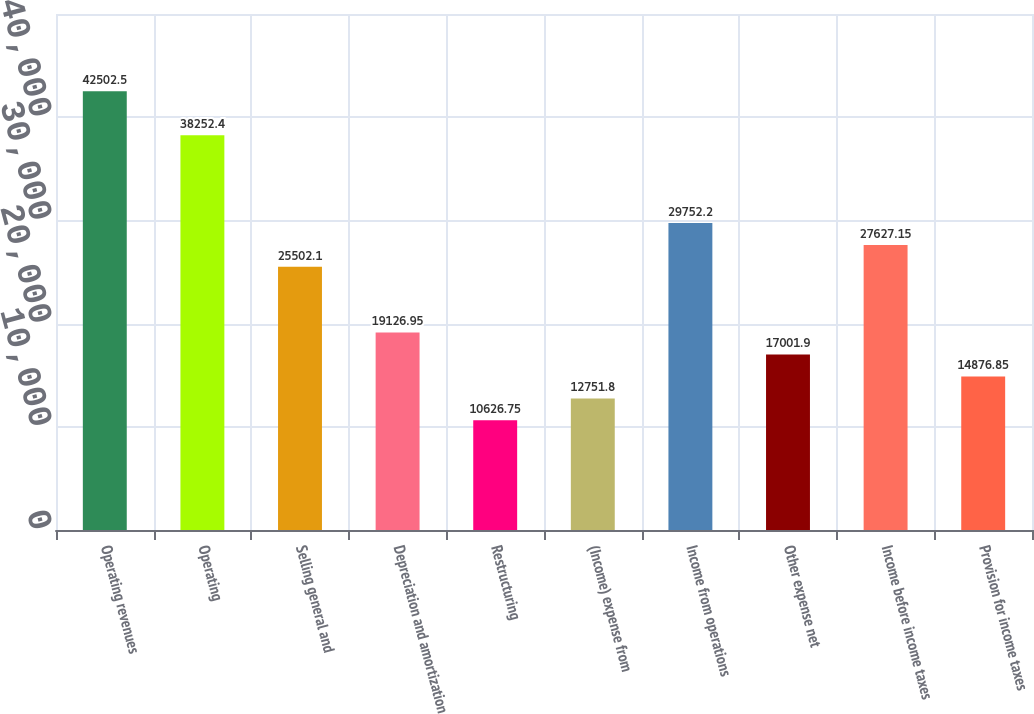<chart> <loc_0><loc_0><loc_500><loc_500><bar_chart><fcel>Operating revenues<fcel>Operating<fcel>Selling general and<fcel>Depreciation and amortization<fcel>Restructuring<fcel>(Income) expense from<fcel>Income from operations<fcel>Other expense net<fcel>Income before income taxes<fcel>Provision for income taxes<nl><fcel>42502.5<fcel>38252.4<fcel>25502.1<fcel>19127<fcel>10626.8<fcel>12751.8<fcel>29752.2<fcel>17001.9<fcel>27627.2<fcel>14876.9<nl></chart> 